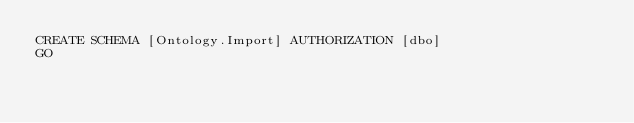Convert code to text. <code><loc_0><loc_0><loc_500><loc_500><_SQL_>CREATE SCHEMA [Ontology.Import] AUTHORIZATION [dbo]
GO
</code> 